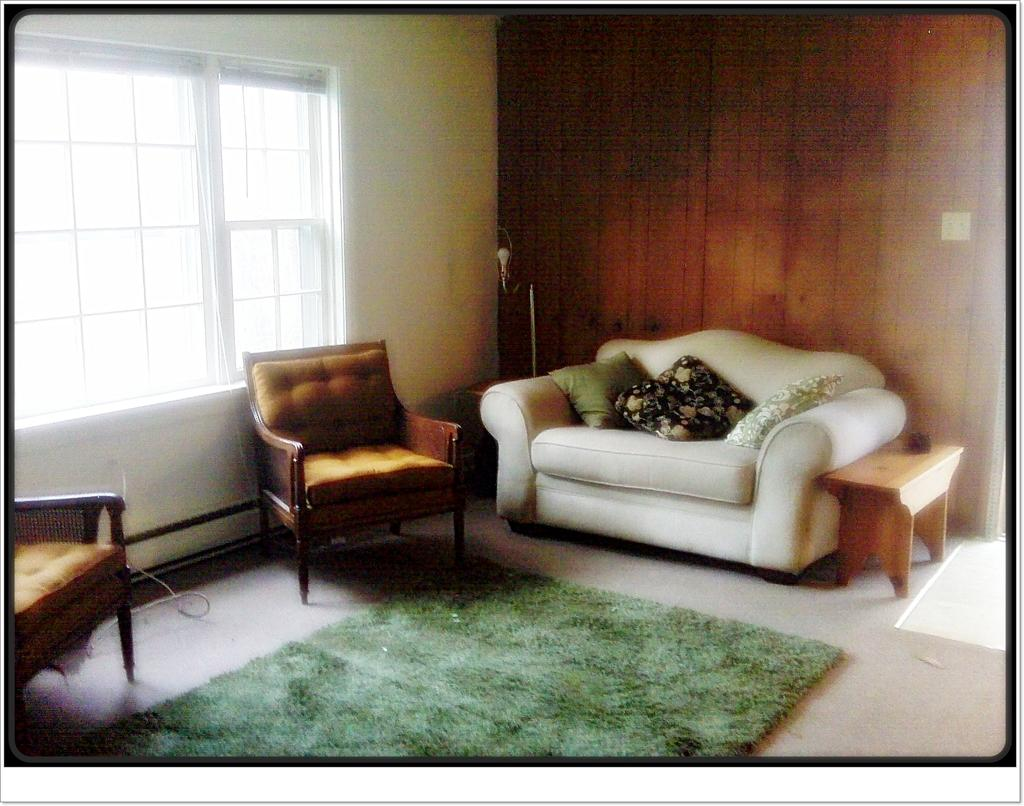What type of furniture is present in the image? There is a sofa set and a table in the image. What can be seen through the window in the image? The image does not show what can be seen through the window. What type of flooring is visible in the image? There is a carpet in the image. What is the background of the image made of? There is a wall in the image. What type of vein is visible on the carpet in the image? There are no veins visible on the carpet in the image. How many corn plants can be seen in the image? There are no corn plants present in the image. 